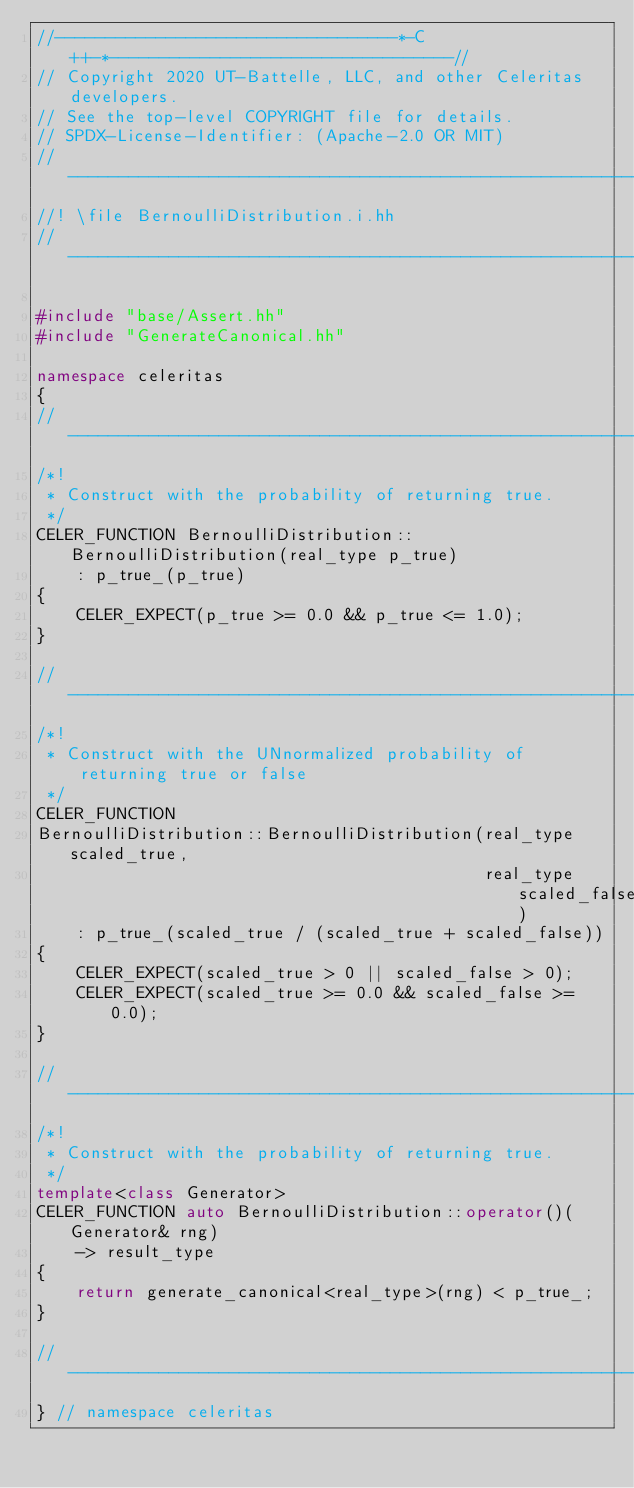<code> <loc_0><loc_0><loc_500><loc_500><_C++_>//----------------------------------*-C++-*----------------------------------//
// Copyright 2020 UT-Battelle, LLC, and other Celeritas developers.
// See the top-level COPYRIGHT file for details.
// SPDX-License-Identifier: (Apache-2.0 OR MIT)
//---------------------------------------------------------------------------//
//! \file BernoulliDistribution.i.hh
//---------------------------------------------------------------------------//

#include "base/Assert.hh"
#include "GenerateCanonical.hh"

namespace celeritas
{
//---------------------------------------------------------------------------//
/*!
 * Construct with the probability of returning true.
 */
CELER_FUNCTION BernoulliDistribution::BernoulliDistribution(real_type p_true)
    : p_true_(p_true)
{
    CELER_EXPECT(p_true >= 0.0 && p_true <= 1.0);
}

//---------------------------------------------------------------------------//
/*!
 * Construct with the UNnormalized probability of returning true or false
 */
CELER_FUNCTION
BernoulliDistribution::BernoulliDistribution(real_type scaled_true,
                                             real_type scaled_false)
    : p_true_(scaled_true / (scaled_true + scaled_false))
{
    CELER_EXPECT(scaled_true > 0 || scaled_false > 0);
    CELER_EXPECT(scaled_true >= 0.0 && scaled_false >= 0.0);
}

//---------------------------------------------------------------------------//
/*!
 * Construct with the probability of returning true.
 */
template<class Generator>
CELER_FUNCTION auto BernoulliDistribution::operator()(Generator& rng)
    -> result_type
{
    return generate_canonical<real_type>(rng) < p_true_;
}

//---------------------------------------------------------------------------//
} // namespace celeritas
</code> 